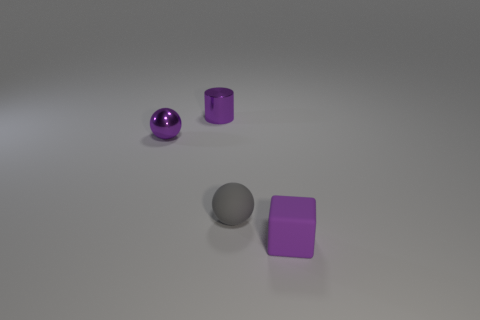Add 3 small metal cylinders. How many objects exist? 7 Subtract all cubes. How many objects are left? 3 Subtract all purple rubber things. Subtract all purple cylinders. How many objects are left? 2 Add 4 purple metal cylinders. How many purple metal cylinders are left? 5 Add 2 blocks. How many blocks exist? 3 Subtract 0 cyan blocks. How many objects are left? 4 